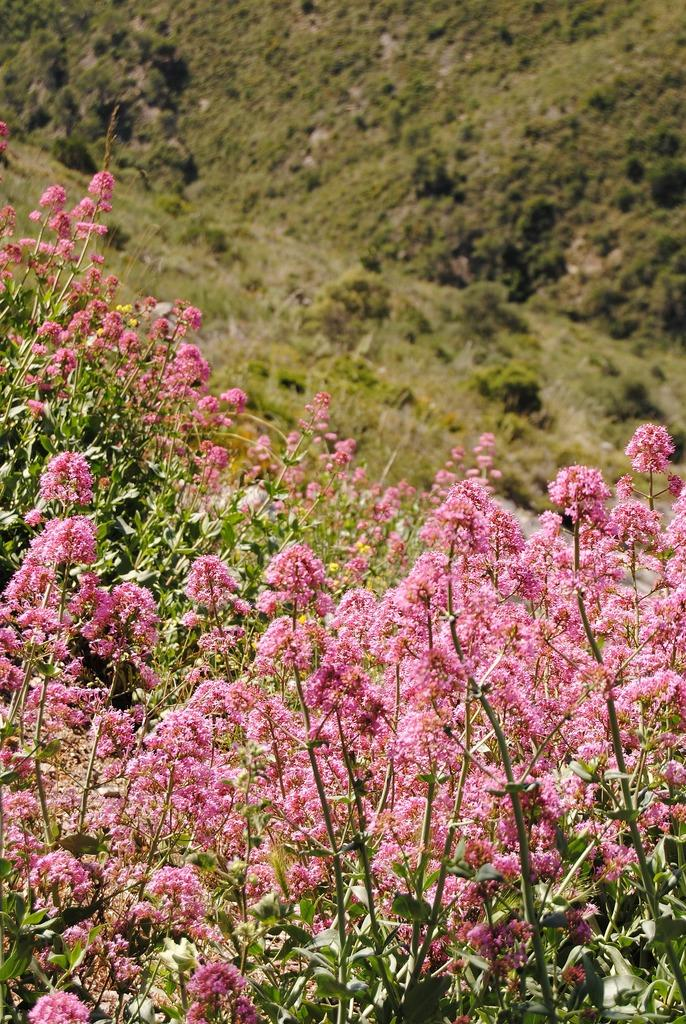What type of flowers are at the bottom of the image? There are pink color flowers at the bottom of the image. What can be seen in the background of the image? There are small plants in the background of the image. What type of sweater is the person wearing in the image? There is no person or sweater present in the image; it only features flowers and small plants. What color is the person's hair in the image? There is no person or hair present in the image; it only features flowers and small plants. 